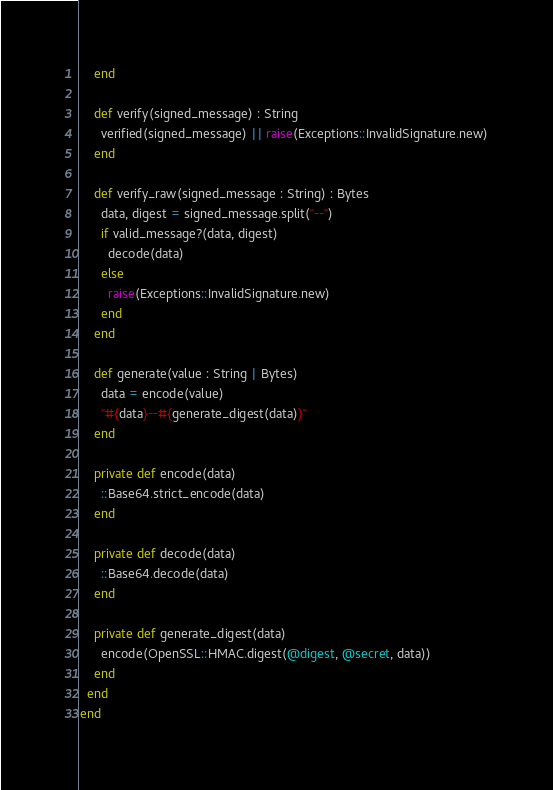<code> <loc_0><loc_0><loc_500><loc_500><_Crystal_>    end

    def verify(signed_message) : String
      verified(signed_message) || raise(Exceptions::InvalidSignature.new)
    end

    def verify_raw(signed_message : String) : Bytes
      data, digest = signed_message.split("--")
      if valid_message?(data, digest)
        decode(data)
      else
        raise(Exceptions::InvalidSignature.new)
      end
    end

    def generate(value : String | Bytes)
      data = encode(value)
      "#{data}--#{generate_digest(data)}"
    end

    private def encode(data)
      ::Base64.strict_encode(data)
    end

    private def decode(data)
      ::Base64.decode(data)
    end

    private def generate_digest(data)
      encode(OpenSSL::HMAC.digest(@digest, @secret, data))
    end
  end
end
</code> 